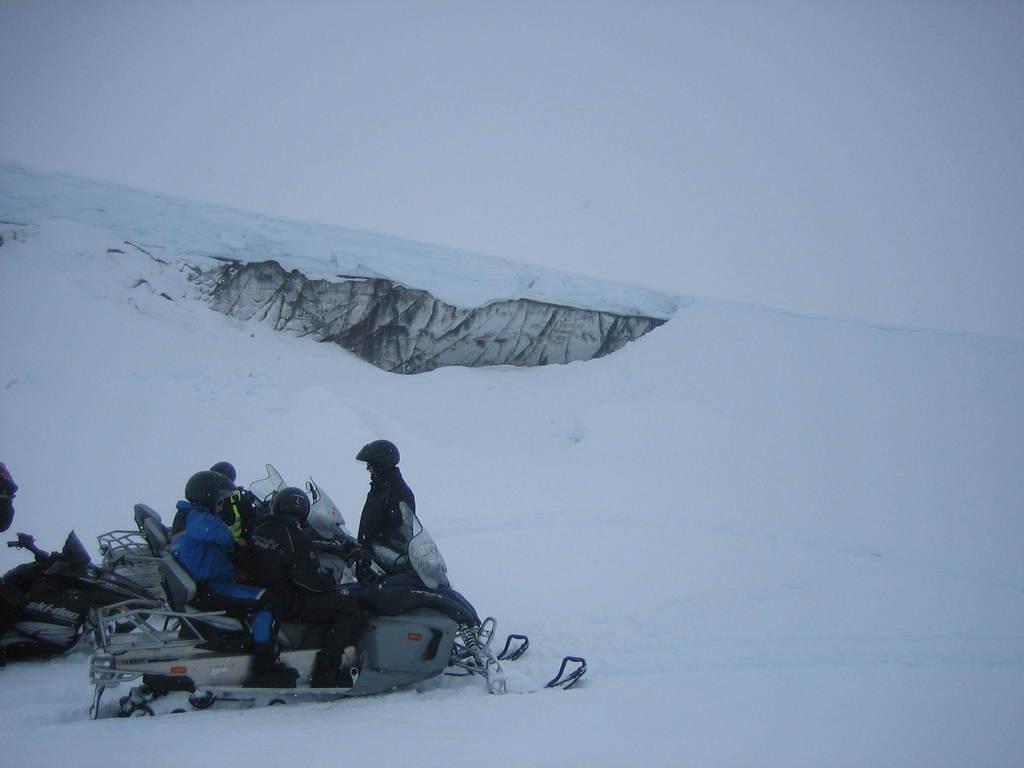Describe this image in one or two sentences. In this image we can see some persons sitting on the vehicle which is on the ice. We can also see a person standing. 